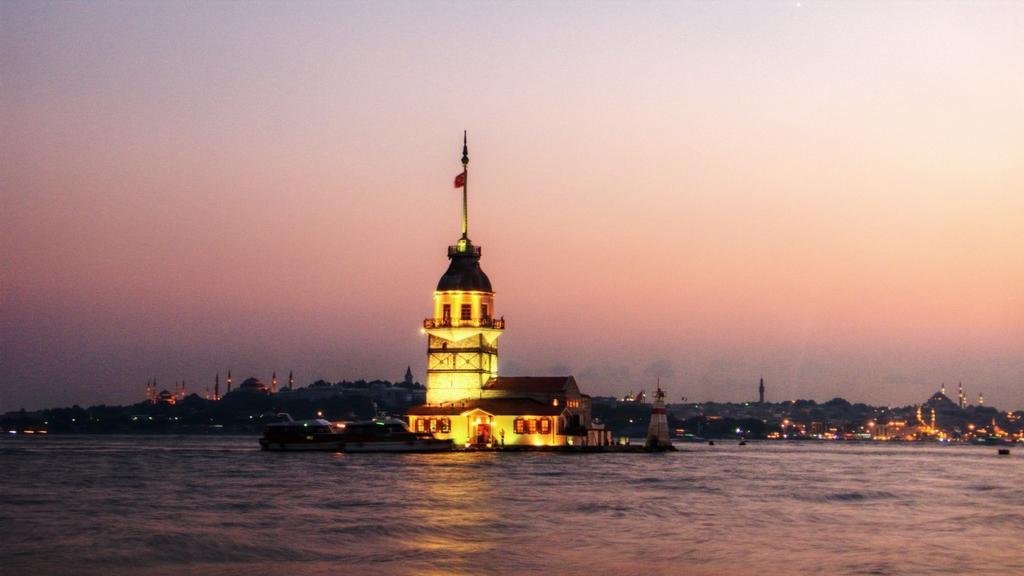Describe this image in one or two sentences. In the image there is a light house in the middle of sea and in the back there are many buildings on the land and above its sky. 